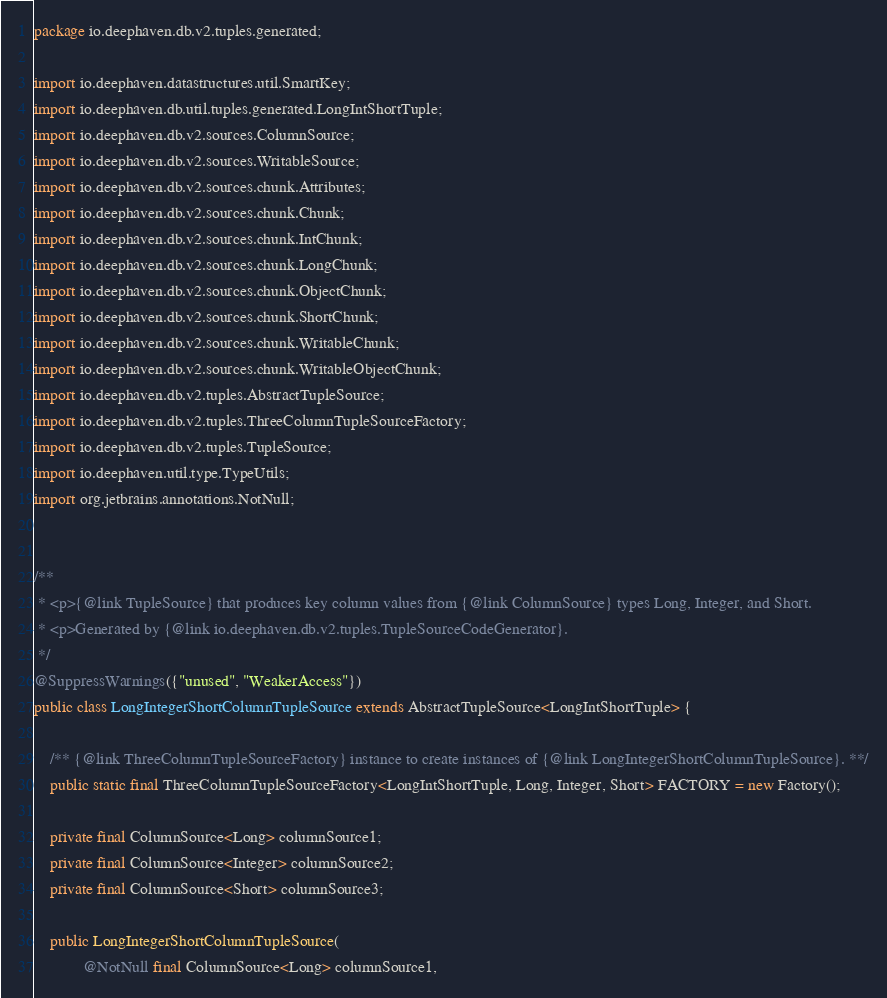<code> <loc_0><loc_0><loc_500><loc_500><_Java_>package io.deephaven.db.v2.tuples.generated;

import io.deephaven.datastructures.util.SmartKey;
import io.deephaven.db.util.tuples.generated.LongIntShortTuple;
import io.deephaven.db.v2.sources.ColumnSource;
import io.deephaven.db.v2.sources.WritableSource;
import io.deephaven.db.v2.sources.chunk.Attributes;
import io.deephaven.db.v2.sources.chunk.Chunk;
import io.deephaven.db.v2.sources.chunk.IntChunk;
import io.deephaven.db.v2.sources.chunk.LongChunk;
import io.deephaven.db.v2.sources.chunk.ObjectChunk;
import io.deephaven.db.v2.sources.chunk.ShortChunk;
import io.deephaven.db.v2.sources.chunk.WritableChunk;
import io.deephaven.db.v2.sources.chunk.WritableObjectChunk;
import io.deephaven.db.v2.tuples.AbstractTupleSource;
import io.deephaven.db.v2.tuples.ThreeColumnTupleSourceFactory;
import io.deephaven.db.v2.tuples.TupleSource;
import io.deephaven.util.type.TypeUtils;
import org.jetbrains.annotations.NotNull;


/**
 * <p>{@link TupleSource} that produces key column values from {@link ColumnSource} types Long, Integer, and Short.
 * <p>Generated by {@link io.deephaven.db.v2.tuples.TupleSourceCodeGenerator}.
 */
@SuppressWarnings({"unused", "WeakerAccess"})
public class LongIntegerShortColumnTupleSource extends AbstractTupleSource<LongIntShortTuple> {

    /** {@link ThreeColumnTupleSourceFactory} instance to create instances of {@link LongIntegerShortColumnTupleSource}. **/
    public static final ThreeColumnTupleSourceFactory<LongIntShortTuple, Long, Integer, Short> FACTORY = new Factory();

    private final ColumnSource<Long> columnSource1;
    private final ColumnSource<Integer> columnSource2;
    private final ColumnSource<Short> columnSource3;

    public LongIntegerShortColumnTupleSource(
            @NotNull final ColumnSource<Long> columnSource1,</code> 